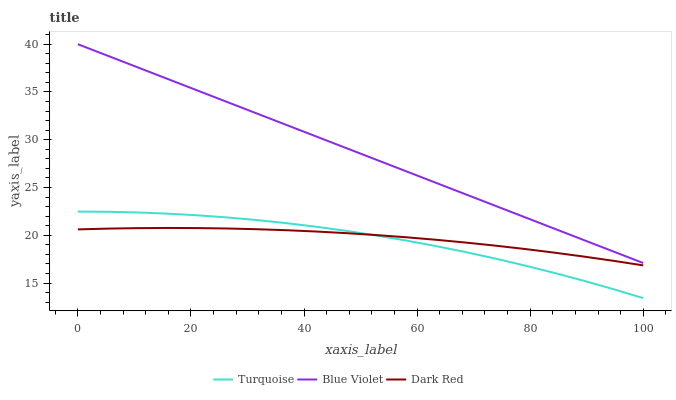Does Turquoise have the minimum area under the curve?
Answer yes or no. Yes. Does Blue Violet have the maximum area under the curve?
Answer yes or no. Yes. Does Blue Violet have the minimum area under the curve?
Answer yes or no. No. Does Turquoise have the maximum area under the curve?
Answer yes or no. No. Is Blue Violet the smoothest?
Answer yes or no. Yes. Is Turquoise the roughest?
Answer yes or no. Yes. Is Turquoise the smoothest?
Answer yes or no. No. Is Blue Violet the roughest?
Answer yes or no. No. Does Blue Violet have the lowest value?
Answer yes or no. No. Does Turquoise have the highest value?
Answer yes or no. No. Is Dark Red less than Blue Violet?
Answer yes or no. Yes. Is Blue Violet greater than Turquoise?
Answer yes or no. Yes. Does Dark Red intersect Blue Violet?
Answer yes or no. No. 